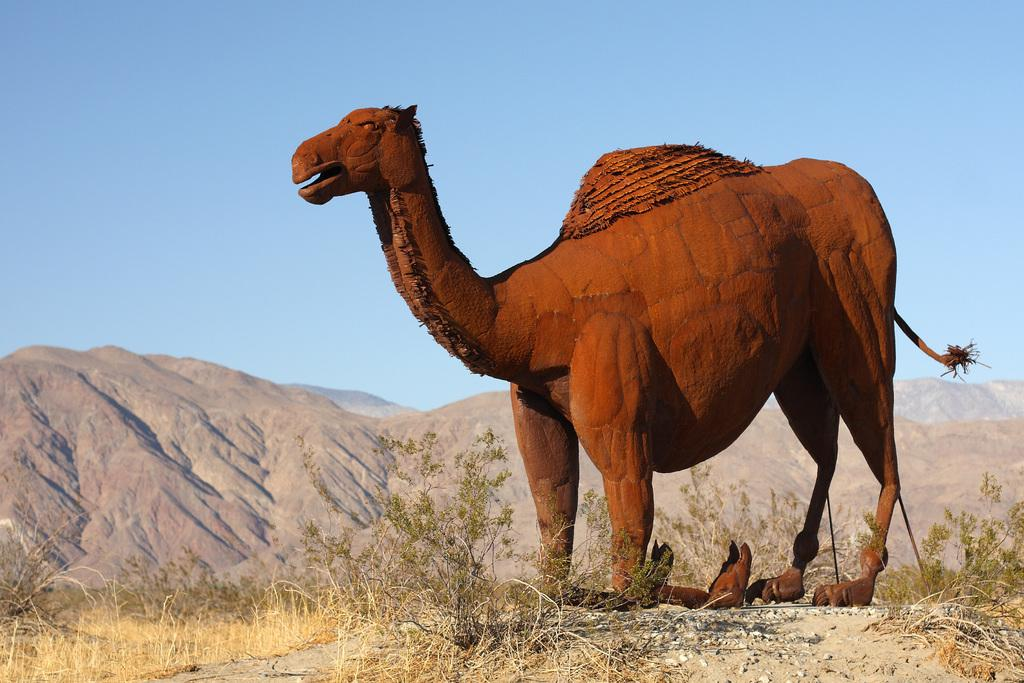What is the main subject of the picture? The main subject of the picture is a statue of a camel. What color is the statue? The statue is brown in color. What can be seen in the background of the picture? Hills are visible in the picture. What type of vegetation is present in the picture? Plants are present in the picture, and grass is on the ground. What is the color of the sky in the picture? The sky is blue in the picture. How many pages are visible in the picture? There are no pages present in the picture; it features a statue of a camel and a natural landscape. Can you tell me how many people are walking in the picture? There are no people visible in the picture, only a statue of a camel and the surrounding environment. 